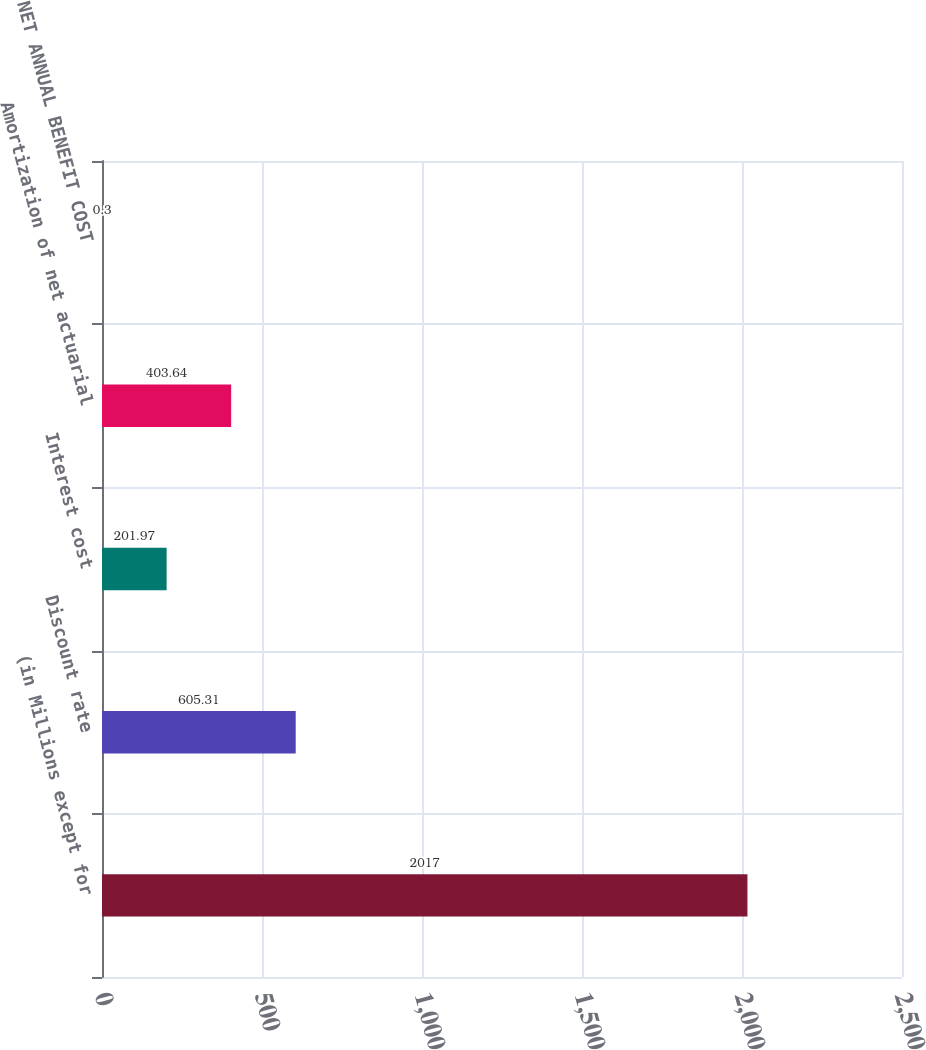Convert chart. <chart><loc_0><loc_0><loc_500><loc_500><bar_chart><fcel>(in Millions except for<fcel>Discount rate<fcel>Interest cost<fcel>Amortization of net actuarial<fcel>NET ANNUAL BENEFIT COST<nl><fcel>2017<fcel>605.31<fcel>201.97<fcel>403.64<fcel>0.3<nl></chart> 